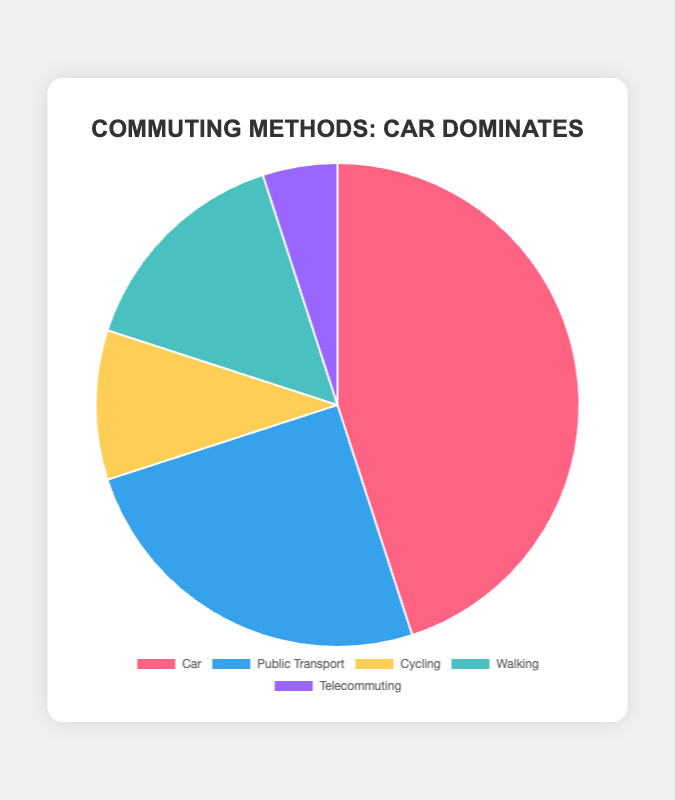What percentage of people commute by car? The chart indicates that 45% of people use cars for commuting.
Answer: 45% How many more people commute by car compared to cycling? The percentage of car commuters is 45%, while cyclists account for 10%. Subtracting the two values, we get 45% - 10% = 35%.
Answer: 35% Which commuting method is the least used? The pie chart shows that telecommuting has the smallest section, indicating it is used by 5% of the people.
Answer: Telecommuting What is the combined percentage of people who either walk or cycle? Walking accounts for 15% and cycling accounts for 10%. Adding these two values, we get 15% + 10% = 25%.
Answer: 25% Which color represents public transport in the pie chart? The chart shows different colors for each commuting method, and public transport is represented by blue.
Answer: Blue Which commuting method has a percentage exactly half of that for cars? The car percentage is 45%, and exactly half of that is 22.5%. The closest commuting method by percentage is public transport at 25%.
Answer: Public Transport How does the percentage of telecommuters compare to the percentage of cyclists? Telecommuting stands at 5% while cycling stands at 10%, making telecommuting less than cycling by 5%.
Answer: Less by 5% If the percentages of car and walking commuters are combined, what fraction of the total commuters is this? Car commuters are 45%, and walking commuters are 15%. Combined, they are 45% + 15% = 60%. Therefore, they make up 60/100 = 3/5 or 60%.
Answer: 60% What is the visual difference between the sections for car and public transport in the pie chart? The section for cars appears significantly larger (nearly double) than that for public transport.
Answer: Car section is larger 